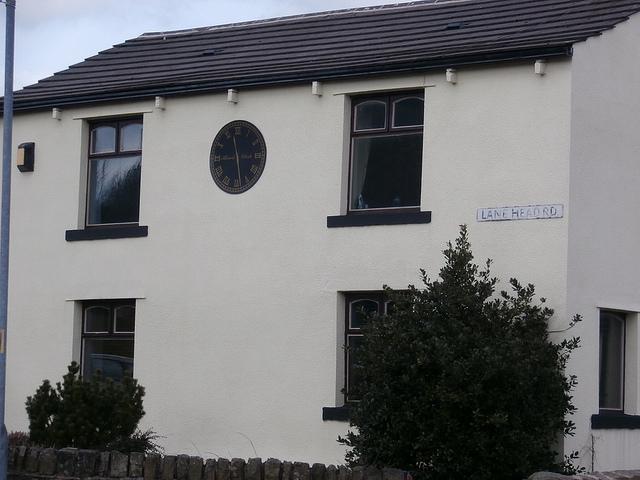What color is the house?
Write a very short answer. White. How many stories is this building?
Be succinct. 2. What are the walls made of?
Keep it brief. Cement. Where is the clock?
Answer briefly. Wall. How many vents are on the roof?
Keep it brief. 2. Do wealthy people likely live here?
Answer briefly. No. What is the house made of?
Write a very short answer. Stucco. How many windows are pictured?
Concise answer only. 5. Is there graffiti on the wall?
Be succinct. No. Which window's shutters are fully open?
Keep it brief. None. What color is the roof?
Be succinct. Black. Is this building handicap accessible?
Quick response, please. No. What time is it?
Be succinct. 11:29. What is the wall made of?
Keep it brief. Plaster. 